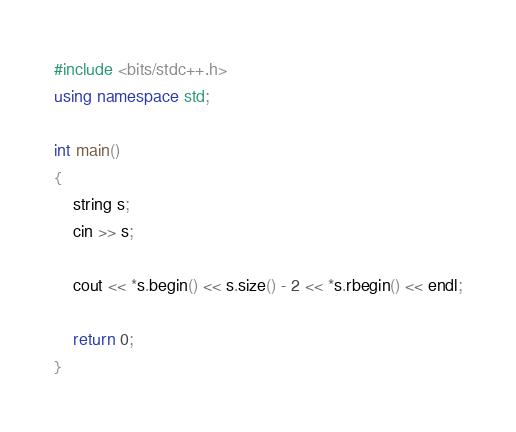<code> <loc_0><loc_0><loc_500><loc_500><_C++_>#include <bits/stdc++.h>
using namespace std;

int main()
{
    string s;
    cin >> s;

    cout << *s.begin() << s.size() - 2 << *s.rbegin() << endl;

    return 0;
}
</code> 